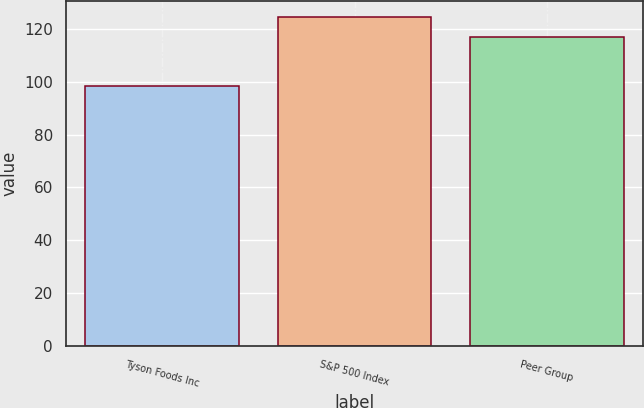Convert chart to OTSL. <chart><loc_0><loc_0><loc_500><loc_500><bar_chart><fcel>Tyson Foods Inc<fcel>S&P 500 Index<fcel>Peer Group<nl><fcel>98.44<fcel>124.37<fcel>116.75<nl></chart> 